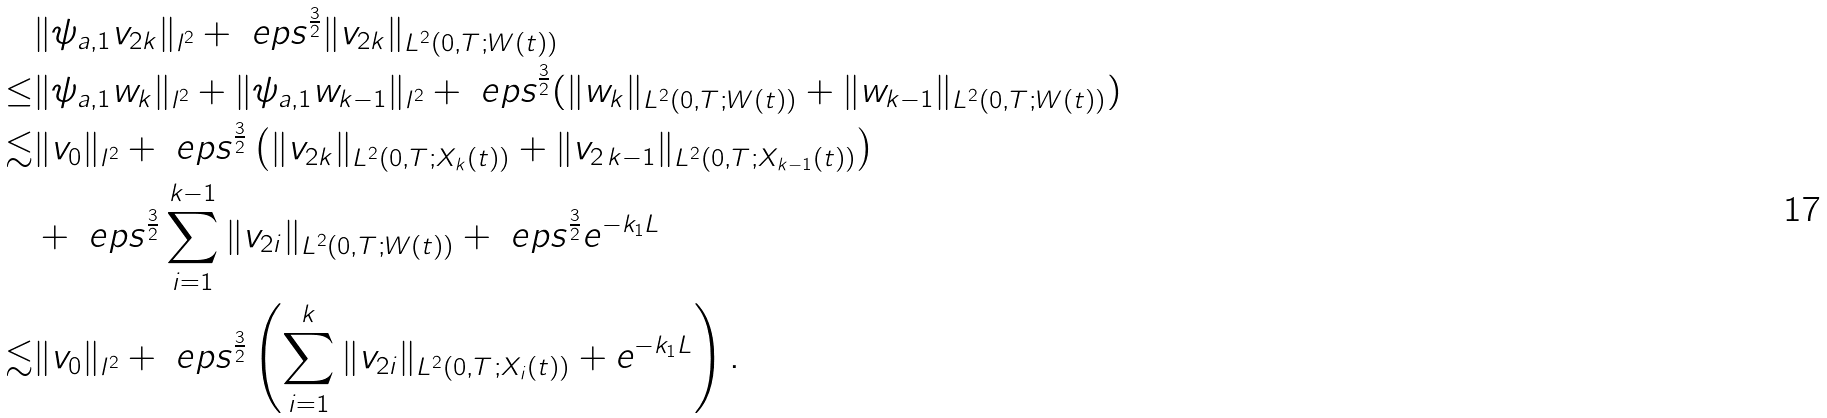Convert formula to latex. <formula><loc_0><loc_0><loc_500><loc_500>& \| \psi _ { a , 1 } v _ { 2 k } \| _ { l ^ { 2 } } + \ e p s ^ { \frac { 3 } { 2 } } \| v _ { 2 k } \| _ { L ^ { 2 } ( 0 , T ; W ( t ) ) } \\ \leq & \| \psi _ { a , 1 } w _ { k } \| _ { l ^ { 2 } } + \| \psi _ { a , 1 } w _ { k - 1 } \| _ { l ^ { 2 } } + \ e p s ^ { \frac { 3 } { 2 } } ( \| w _ { k } \| _ { L ^ { 2 } ( 0 , T ; W ( t ) ) } + \| w _ { k - 1 } \| _ { L ^ { 2 } ( 0 , T ; W ( t ) ) } ) \\ \lesssim & \| v _ { 0 } \| _ { l ^ { 2 } } + \ e p s ^ { \frac { 3 } { 2 } } \left ( \| v _ { 2 k } \| _ { L ^ { 2 } ( 0 , T ; X _ { k } ( t ) ) } + \| v _ { 2 \, k - 1 } \| _ { L ^ { 2 } ( 0 , T ; X _ { k - 1 } ( t ) ) } \right ) \\ & + \ e p s ^ { \frac { 3 } { 2 } } \sum _ { i = 1 } ^ { k - 1 } \| v _ { 2 i } \| _ { L ^ { 2 } ( 0 , T ; W ( t ) ) } + \ e p s ^ { \frac { 3 } { 2 } } e ^ { - k _ { 1 } L } \\ \lesssim & \| v _ { 0 } \| _ { l ^ { 2 } } + \ e p s ^ { \frac { 3 } { 2 } } \left ( \sum _ { i = 1 } ^ { k } \| v _ { 2 i } \| _ { L ^ { 2 } ( 0 , T ; X _ { i } ( t ) ) } + e ^ { - k _ { 1 } L } \right ) .</formula> 